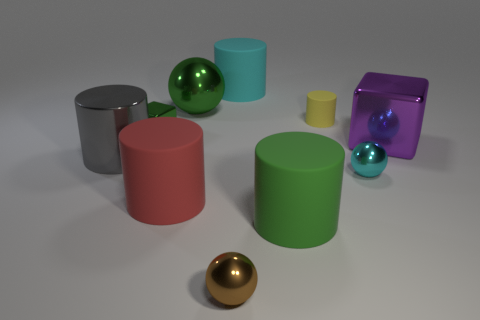Subtract all brown spheres. How many spheres are left? 2 Subtract all tiny cylinders. How many cylinders are left? 4 Subtract all big spheres. Subtract all gray things. How many objects are left? 8 Add 2 large shiny cubes. How many large shiny cubes are left? 3 Add 4 large purple shiny objects. How many large purple shiny objects exist? 5 Subtract 0 yellow cubes. How many objects are left? 10 Subtract all spheres. How many objects are left? 7 Subtract all red spheres. Subtract all gray cylinders. How many spheres are left? 3 Subtract all brown cubes. How many yellow spheres are left? 0 